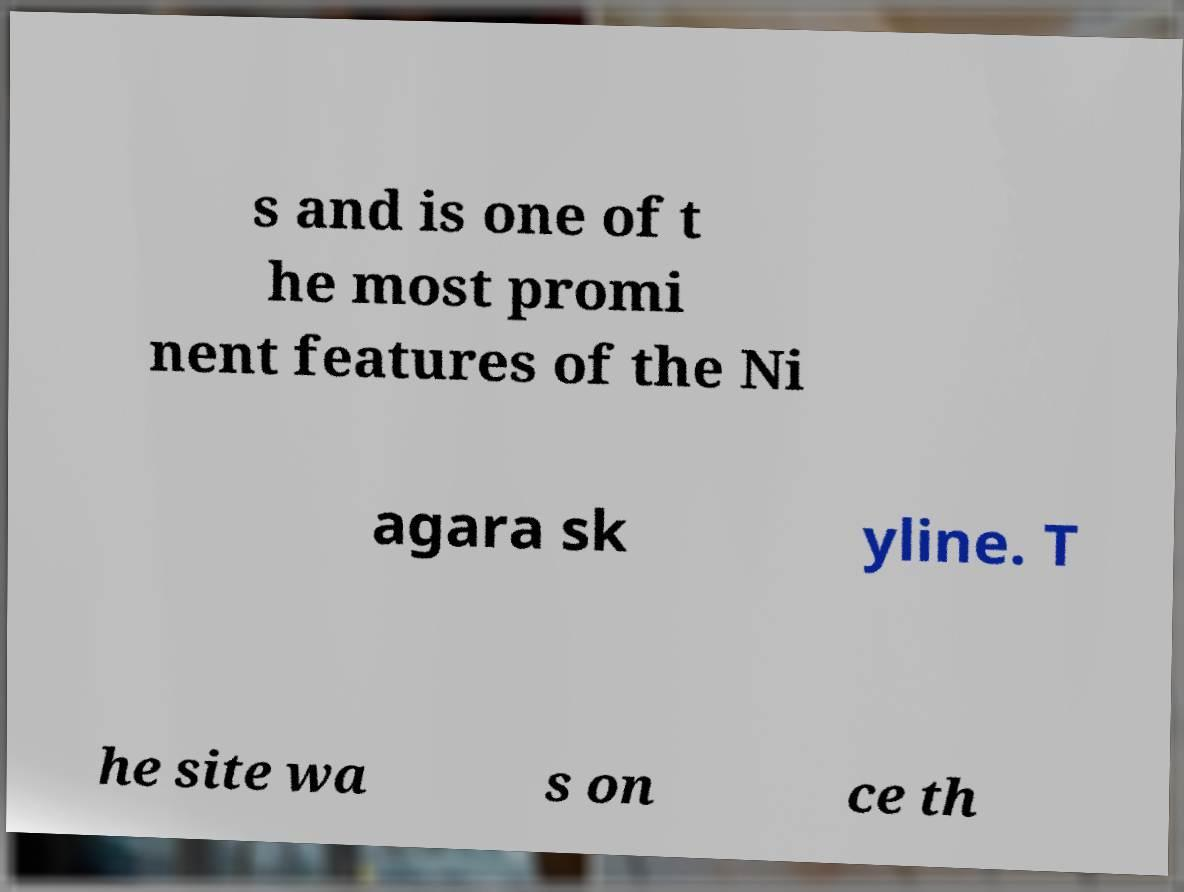For documentation purposes, I need the text within this image transcribed. Could you provide that? s and is one of t he most promi nent features of the Ni agara sk yline. T he site wa s on ce th 